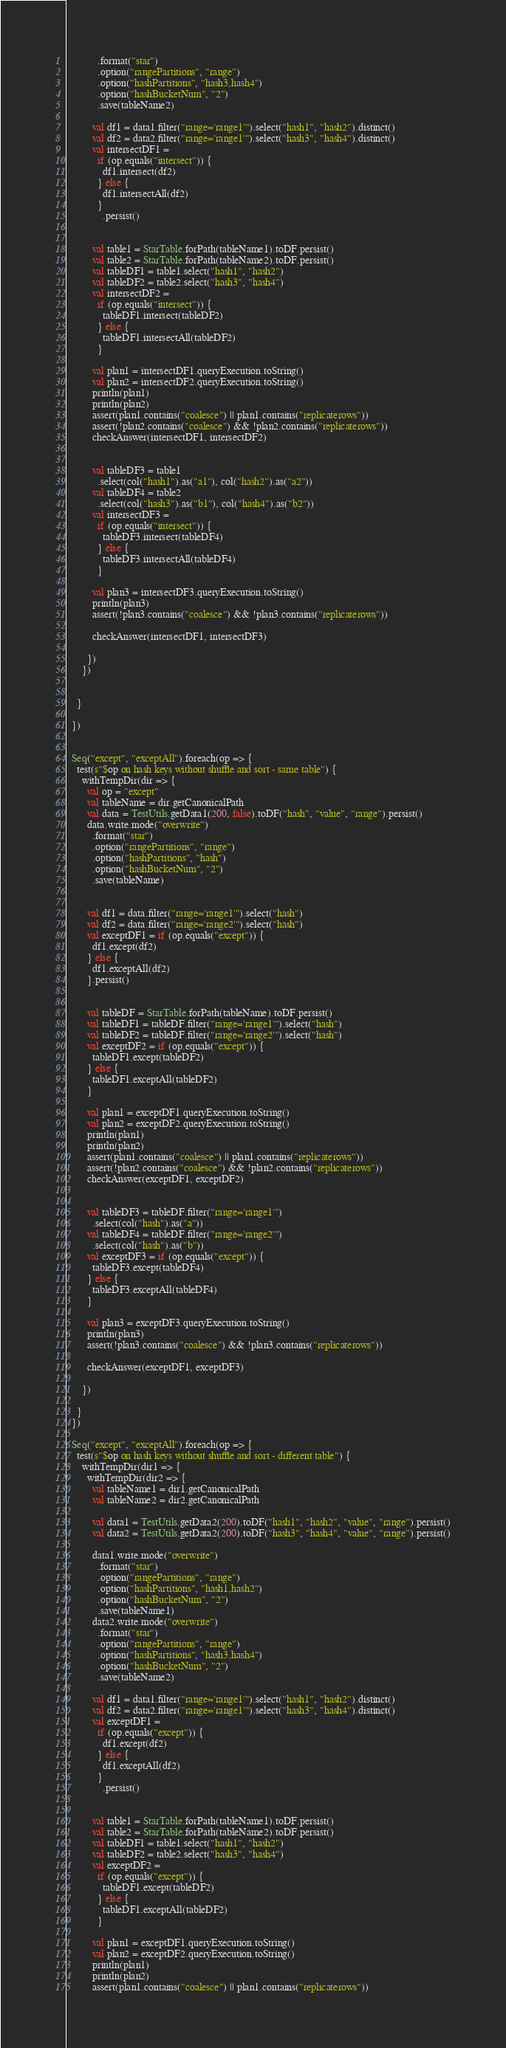<code> <loc_0><loc_0><loc_500><loc_500><_Scala_>            .format("star")
            .option("rangePartitions", "range")
            .option("hashPartitions", "hash3,hash4")
            .option("hashBucketNum", "2")
            .save(tableName2)

          val df1 = data1.filter("range='range1'").select("hash1", "hash2").distinct()
          val df2 = data2.filter("range='range1'").select("hash3", "hash4").distinct()
          val intersectDF1 =
            if (op.equals("intersect")) {
              df1.intersect(df2)
            } else {
              df1.intersectAll(df2)
            }
              .persist()


          val table1 = StarTable.forPath(tableName1).toDF.persist()
          val table2 = StarTable.forPath(tableName2).toDF.persist()
          val tableDF1 = table1.select("hash1", "hash2")
          val tableDF2 = table2.select("hash3", "hash4")
          val intersectDF2 =
            if (op.equals("intersect")) {
              tableDF1.intersect(tableDF2)
            } else {
              tableDF1.intersectAll(tableDF2)
            }

          val plan1 = intersectDF1.queryExecution.toString()
          val plan2 = intersectDF2.queryExecution.toString()
          println(plan1)
          println(plan2)
          assert(plan1.contains("coalesce") || plan1.contains("replicaterows"))
          assert(!plan2.contains("coalesce") && !plan2.contains("replicaterows"))
          checkAnswer(intersectDF1, intersectDF2)


          val tableDF3 = table1
            .select(col("hash1").as("a1"), col("hash2").as("a2"))
          val tableDF4 = table2
            .select(col("hash3").as("b1"), col("hash4").as("b2"))
          val intersectDF3 =
            if (op.equals("intersect")) {
              tableDF3.intersect(tableDF4)
            } else {
              tableDF3.intersectAll(tableDF4)
            }

          val plan3 = intersectDF3.queryExecution.toString()
          println(plan3)
          assert(!plan3.contains("coalesce") && !plan3.contains("replicaterows"))

          checkAnswer(intersectDF1, intersectDF3)

        })
      })


    }

  })


  Seq("except", "exceptAll").foreach(op => {
    test(s"$op on hash keys without shuffle and sort - same table") {
      withTempDir(dir => {
        val op = "except"
        val tableName = dir.getCanonicalPath
        val data = TestUtils.getData1(200, false).toDF("hash", "value", "range").persist()
        data.write.mode("overwrite")
          .format("star")
          .option("rangePartitions", "range")
          .option("hashPartitions", "hash")
          .option("hashBucketNum", "2")
          .save(tableName)


        val df1 = data.filter("range='range1'").select("hash")
        val df2 = data.filter("range='range2'").select("hash")
        val exceptDF1 = if (op.equals("except")) {
          df1.except(df2)
        } else {
          df1.exceptAll(df2)
        }.persist()


        val tableDF = StarTable.forPath(tableName).toDF.persist()
        val tableDF1 = tableDF.filter("range='range1'").select("hash")
        val tableDF2 = tableDF.filter("range='range2'").select("hash")
        val exceptDF2 = if (op.equals("except")) {
          tableDF1.except(tableDF2)
        } else {
          tableDF1.exceptAll(tableDF2)
        }

        val plan1 = exceptDF1.queryExecution.toString()
        val plan2 = exceptDF2.queryExecution.toString()
        println(plan1)
        println(plan2)
        assert(plan1.contains("coalesce") || plan1.contains("replicaterows"))
        assert(!plan2.contains("coalesce") && !plan2.contains("replicaterows"))
        checkAnswer(exceptDF1, exceptDF2)


        val tableDF3 = tableDF.filter("range='range1'")
          .select(col("hash").as("a"))
        val tableDF4 = tableDF.filter("range='range2'")
          .select(col("hash").as("b"))
        val exceptDF3 = if (op.equals("except")) {
          tableDF3.except(tableDF4)
        } else {
          tableDF3.exceptAll(tableDF4)
        }

        val plan3 = exceptDF3.queryExecution.toString()
        println(plan3)
        assert(!plan3.contains("coalesce") && !plan3.contains("replicaterows"))

        checkAnswer(exceptDF1, exceptDF3)

      })

    }
  })

  Seq("except", "exceptAll").foreach(op => {
    test(s"$op on hash keys without shuffle and sort - different table") {
      withTempDir(dir1 => {
        withTempDir(dir2 => {
          val tableName1 = dir1.getCanonicalPath
          val tableName2 = dir2.getCanonicalPath

          val data1 = TestUtils.getData2(200).toDF("hash1", "hash2", "value", "range").persist()
          val data2 = TestUtils.getData2(200).toDF("hash3", "hash4", "value", "range").persist()

          data1.write.mode("overwrite")
            .format("star")
            .option("rangePartitions", "range")
            .option("hashPartitions", "hash1,hash2")
            .option("hashBucketNum", "2")
            .save(tableName1)
          data2.write.mode("overwrite")
            .format("star")
            .option("rangePartitions", "range")
            .option("hashPartitions", "hash3,hash4")
            .option("hashBucketNum", "2")
            .save(tableName2)

          val df1 = data1.filter("range='range1'").select("hash1", "hash2").distinct()
          val df2 = data2.filter("range='range1'").select("hash3", "hash4").distinct()
          val exceptDF1 =
            if (op.equals("except")) {
              df1.except(df2)
            } else {
              df1.exceptAll(df2)
            }
              .persist()


          val table1 = StarTable.forPath(tableName1).toDF.persist()
          val table2 = StarTable.forPath(tableName2).toDF.persist()
          val tableDF1 = table1.select("hash1", "hash2")
          val tableDF2 = table2.select("hash3", "hash4")
          val exceptDF2 =
            if (op.equals("except")) {
              tableDF1.except(tableDF2)
            } else {
              tableDF1.exceptAll(tableDF2)
            }

          val plan1 = exceptDF1.queryExecution.toString()
          val plan2 = exceptDF2.queryExecution.toString()
          println(plan1)
          println(plan2)
          assert(plan1.contains("coalesce") || plan1.contains("replicaterows"))</code> 